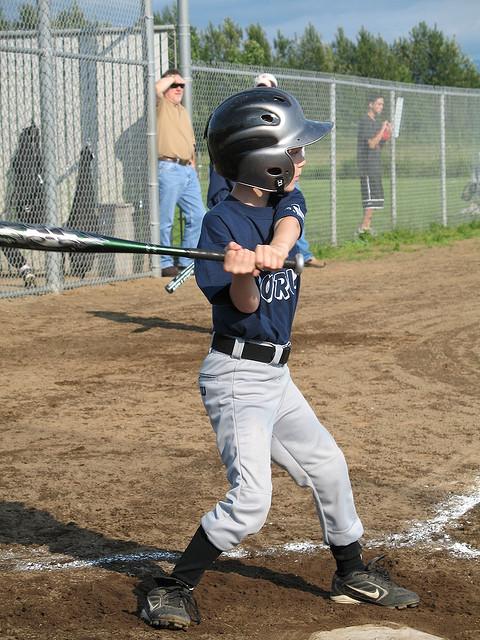Is the boy tall enough to play baseball?
Be succinct. Yes. Is this a child or an adult?
Keep it brief. Child. What sort of shoes is he wearing?
Keep it brief. Cleats. Is this child wearing shoes?
Quick response, please. Yes. 